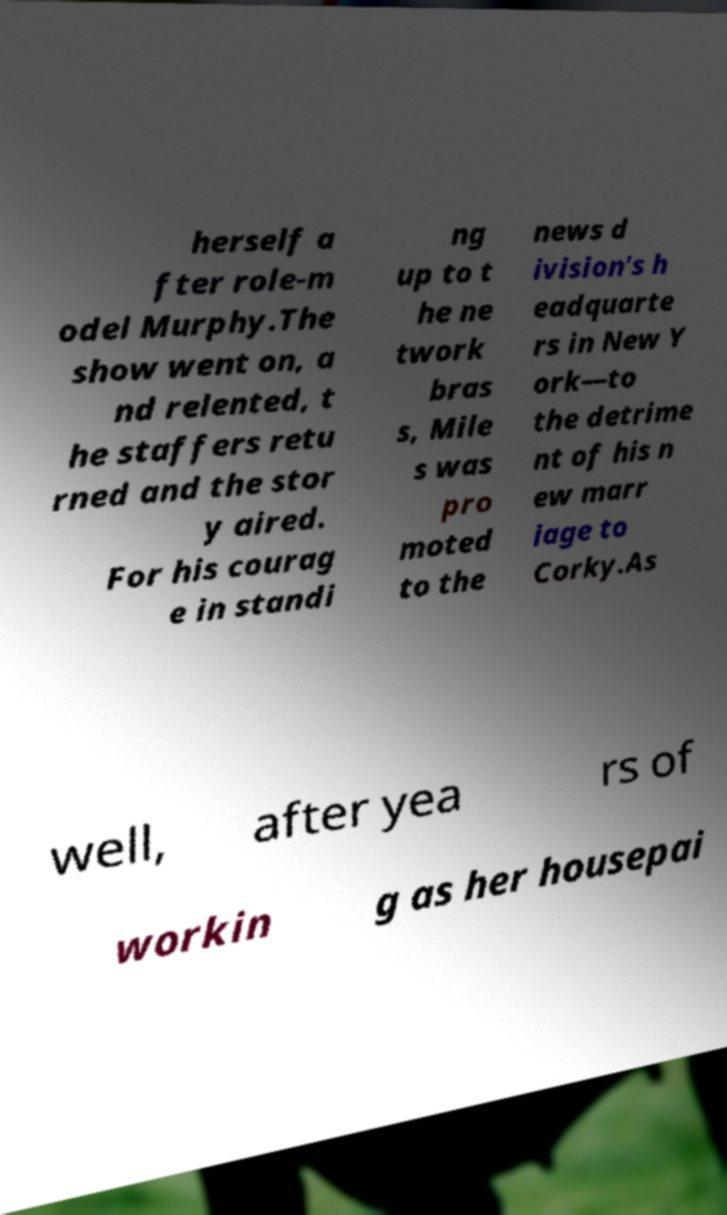What messages or text are displayed in this image? I need them in a readable, typed format. herself a fter role-m odel Murphy.The show went on, a nd relented, t he staffers retu rned and the stor y aired. For his courag e in standi ng up to t he ne twork bras s, Mile s was pro moted to the news d ivision's h eadquarte rs in New Y ork—to the detrime nt of his n ew marr iage to Corky.As well, after yea rs of workin g as her housepai 